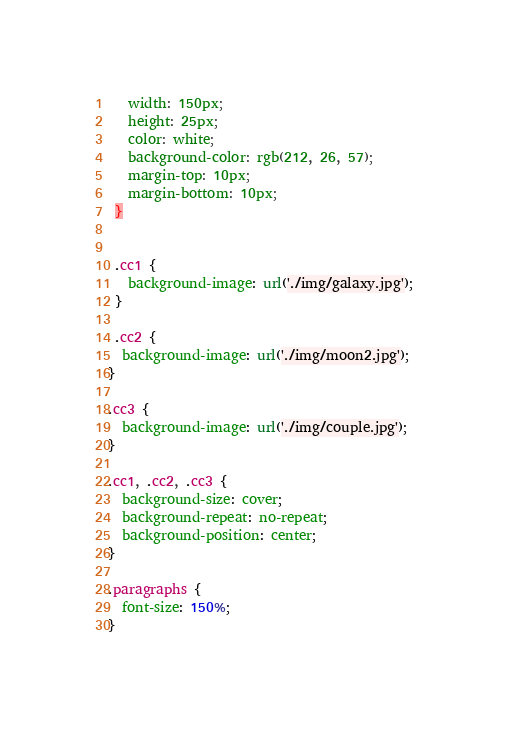Convert code to text. <code><loc_0><loc_0><loc_500><loc_500><_CSS_>   width: 150px;
   height: 25px;
   color: white;
   background-color: rgb(212, 26, 57);
   margin-top: 10px;
   margin-bottom: 10px;
 }
 
 
 .cc1 {
   background-image: url('./img/galaxy.jpg');
 }

 .cc2 {
  background-image: url('./img/moon2.jpg');
}

.cc3 {
  background-image: url('./img/couple.jpg');
}

.cc1, .cc2, .cc3 {
  background-size: cover;
  background-repeat: no-repeat;
  background-position: center;
}

.paragraphs {
  font-size: 150%;
}</code> 